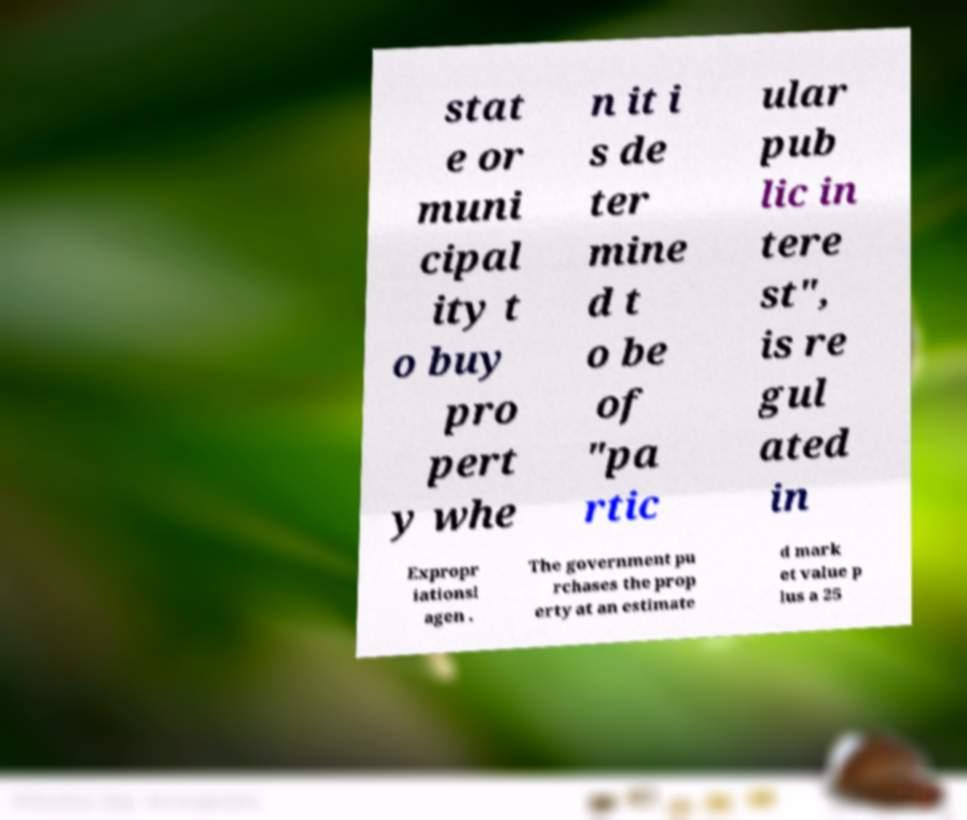There's text embedded in this image that I need extracted. Can you transcribe it verbatim? stat e or muni cipal ity t o buy pro pert y whe n it i s de ter mine d t o be of "pa rtic ular pub lic in tere st", is re gul ated in Expropr iationsl agen . The government pu rchases the prop erty at an estimate d mark et value p lus a 25 